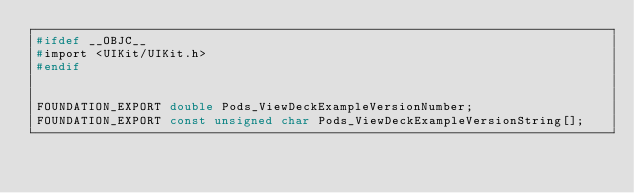<code> <loc_0><loc_0><loc_500><loc_500><_C_>#ifdef __OBJC__
#import <UIKit/UIKit.h>
#endif


FOUNDATION_EXPORT double Pods_ViewDeckExampleVersionNumber;
FOUNDATION_EXPORT const unsigned char Pods_ViewDeckExampleVersionString[];

</code> 